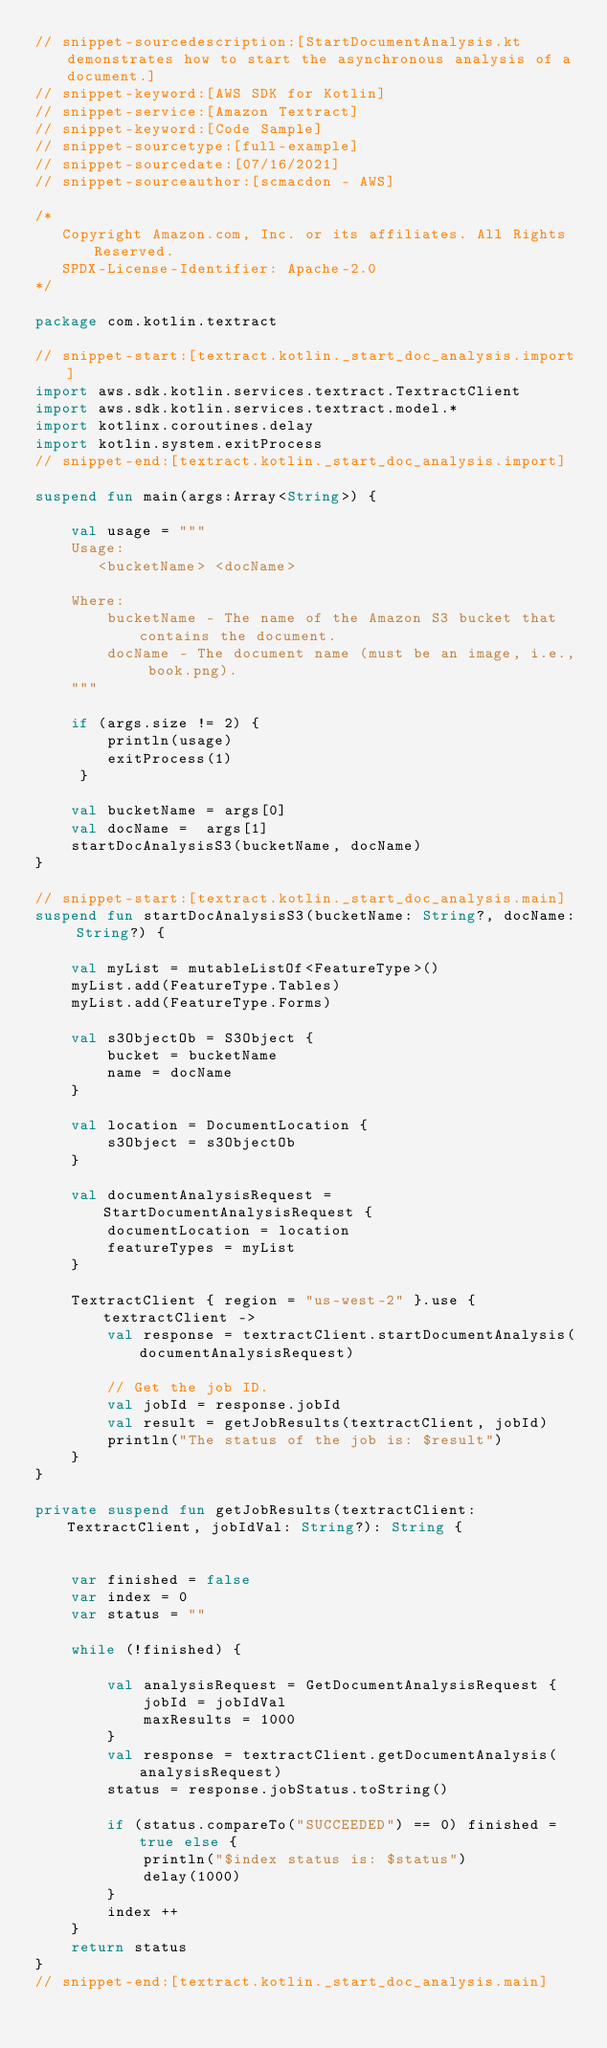Convert code to text. <code><loc_0><loc_0><loc_500><loc_500><_Kotlin_>// snippet-sourcedescription:[StartDocumentAnalysis.kt demonstrates how to start the asynchronous analysis of a document.]
// snippet-keyword:[AWS SDK for Kotlin]
// snippet-service:[Amazon Textract]
// snippet-keyword:[Code Sample]
// snippet-sourcetype:[full-example]
// snippet-sourcedate:[07/16/2021]
// snippet-sourceauthor:[scmacdon - AWS]

/*
   Copyright Amazon.com, Inc. or its affiliates. All Rights Reserved.
   SPDX-License-Identifier: Apache-2.0
*/

package com.kotlin.textract

// snippet-start:[textract.kotlin._start_doc_analysis.import]
import aws.sdk.kotlin.services.textract.TextractClient
import aws.sdk.kotlin.services.textract.model.*
import kotlinx.coroutines.delay
import kotlin.system.exitProcess
// snippet-end:[textract.kotlin._start_doc_analysis.import]

suspend fun main(args:Array<String>) {

    val usage = """
    Usage:
       <bucketName> <docName> 

    Where:
        bucketName - The name of the Amazon S3 bucket that contains the document.
        docName - The document name (must be an image, i.e., book.png). 
    """

    if (args.size != 2) {
        println(usage)
        exitProcess(1)
     }

    val bucketName = args[0]
    val docName =  args[1]
    startDocAnalysisS3(bucketName, docName)
}

// snippet-start:[textract.kotlin._start_doc_analysis.main]
suspend fun startDocAnalysisS3(bucketName: String?, docName: String?) {

    val myList = mutableListOf<FeatureType>()
    myList.add(FeatureType.Tables)
    myList.add(FeatureType.Forms)

    val s3ObjectOb = S3Object {
        bucket = bucketName
        name = docName
    }

    val location = DocumentLocation {
        s3Object = s3ObjectOb
    }

    val documentAnalysisRequest = StartDocumentAnalysisRequest {
        documentLocation = location
        featureTypes = myList
    }

    TextractClient { region = "us-west-2" }.use { textractClient ->
        val response = textractClient.startDocumentAnalysis(documentAnalysisRequest)

        // Get the job ID.
        val jobId = response.jobId
        val result = getJobResults(textractClient, jobId)
        println("The status of the job is: $result")
    }
}

private suspend fun getJobResults(textractClient: TextractClient, jobIdVal: String?): String {


    var finished = false
    var index = 0
    var status = ""

    while (!finished) {

        val analysisRequest = GetDocumentAnalysisRequest {
            jobId = jobIdVal
            maxResults = 1000
        }
        val response = textractClient.getDocumentAnalysis(analysisRequest)
        status = response.jobStatus.toString()

        if (status.compareTo("SUCCEEDED") == 0) finished = true else {
            println("$index status is: $status")
            delay(1000)
        }
        index ++
    }
    return status
}
// snippet-end:[textract.kotlin._start_doc_analysis.main]
</code> 